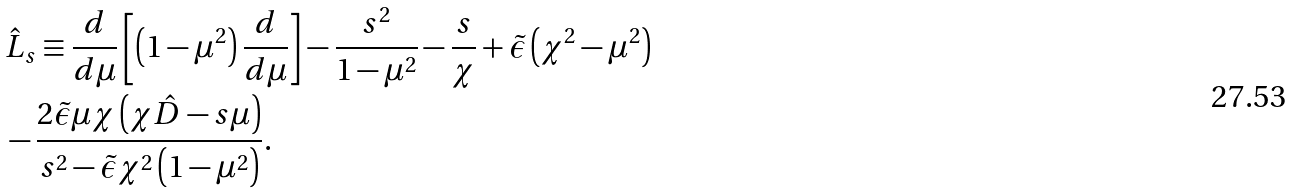Convert formula to latex. <formula><loc_0><loc_0><loc_500><loc_500>& \hat { L } _ { s } \equiv \frac { d } { d \mu } \left [ \left ( 1 - \mu ^ { 2 } \right ) \frac { d } { d \mu } \right ] - \frac { s ^ { 2 } } { 1 - \mu ^ { 2 } } - \frac { s } { \chi } + \tilde { \epsilon } \left ( \chi ^ { 2 } - \mu ^ { 2 } \right ) \\ & - \frac { 2 \tilde { \epsilon } \mu \chi \left ( \chi \hat { D } - s \mu \right ) } { s ^ { 2 } - \tilde { \epsilon } \chi ^ { 2 } \left ( 1 - \mu ^ { 2 } \right ) } . \\</formula> 